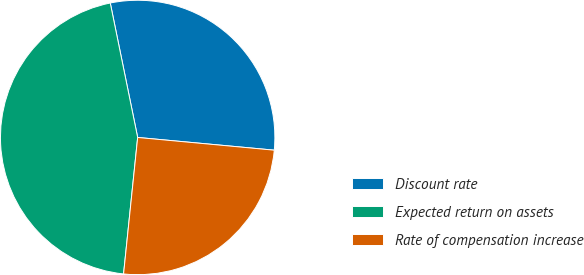Convert chart. <chart><loc_0><loc_0><loc_500><loc_500><pie_chart><fcel>Discount rate<fcel>Expected return on assets<fcel>Rate of compensation increase<nl><fcel>29.68%<fcel>45.16%<fcel>25.16%<nl></chart> 